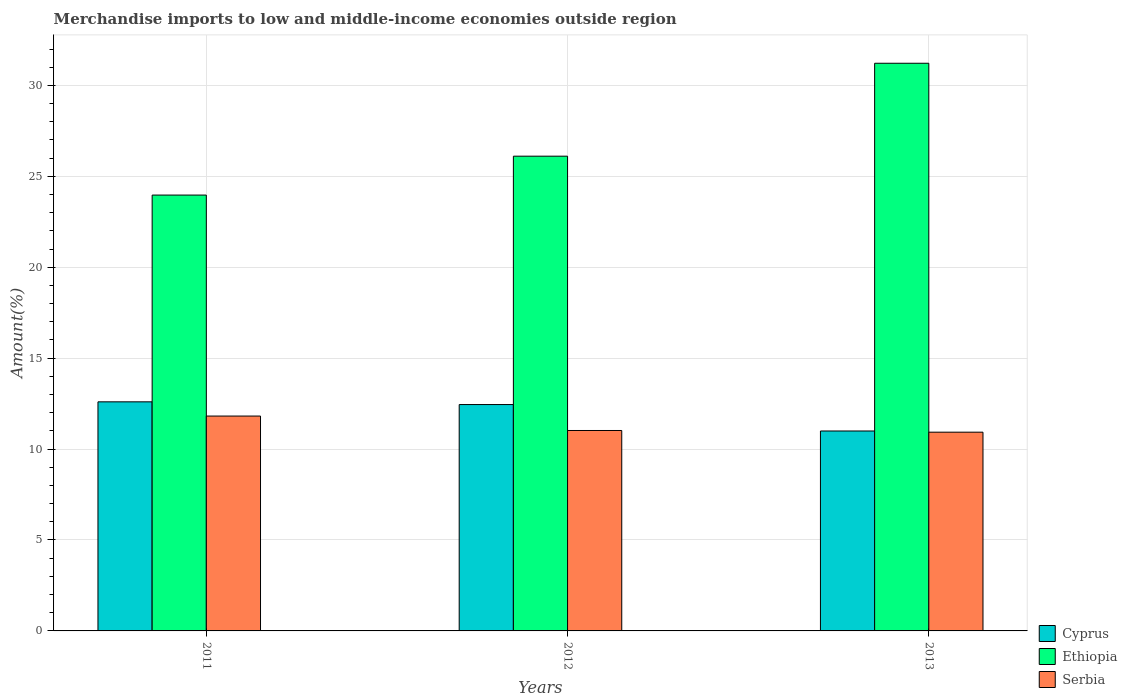Are the number of bars per tick equal to the number of legend labels?
Give a very brief answer. Yes. How many bars are there on the 3rd tick from the left?
Your answer should be compact. 3. What is the label of the 3rd group of bars from the left?
Offer a terse response. 2013. In how many cases, is the number of bars for a given year not equal to the number of legend labels?
Offer a terse response. 0. What is the percentage of amount earned from merchandise imports in Serbia in 2011?
Offer a terse response. 11.82. Across all years, what is the maximum percentage of amount earned from merchandise imports in Ethiopia?
Your response must be concise. 31.22. Across all years, what is the minimum percentage of amount earned from merchandise imports in Ethiopia?
Your response must be concise. 23.97. In which year was the percentage of amount earned from merchandise imports in Serbia maximum?
Ensure brevity in your answer.  2011. In which year was the percentage of amount earned from merchandise imports in Serbia minimum?
Ensure brevity in your answer.  2013. What is the total percentage of amount earned from merchandise imports in Ethiopia in the graph?
Provide a succinct answer. 81.29. What is the difference between the percentage of amount earned from merchandise imports in Serbia in 2011 and that in 2013?
Provide a short and direct response. 0.89. What is the difference between the percentage of amount earned from merchandise imports in Cyprus in 2011 and the percentage of amount earned from merchandise imports in Serbia in 2013?
Your answer should be compact. 1.67. What is the average percentage of amount earned from merchandise imports in Ethiopia per year?
Keep it short and to the point. 27.1. In the year 2013, what is the difference between the percentage of amount earned from merchandise imports in Cyprus and percentage of amount earned from merchandise imports in Ethiopia?
Your response must be concise. -20.22. In how many years, is the percentage of amount earned from merchandise imports in Ethiopia greater than 21 %?
Provide a short and direct response. 3. What is the ratio of the percentage of amount earned from merchandise imports in Serbia in 2012 to that in 2013?
Your answer should be compact. 1.01. Is the difference between the percentage of amount earned from merchandise imports in Cyprus in 2012 and 2013 greater than the difference between the percentage of amount earned from merchandise imports in Ethiopia in 2012 and 2013?
Your response must be concise. Yes. What is the difference between the highest and the second highest percentage of amount earned from merchandise imports in Cyprus?
Your response must be concise. 0.15. What is the difference between the highest and the lowest percentage of amount earned from merchandise imports in Serbia?
Keep it short and to the point. 0.89. In how many years, is the percentage of amount earned from merchandise imports in Cyprus greater than the average percentage of amount earned from merchandise imports in Cyprus taken over all years?
Your answer should be compact. 2. What does the 2nd bar from the left in 2012 represents?
Provide a succinct answer. Ethiopia. What does the 2nd bar from the right in 2013 represents?
Keep it short and to the point. Ethiopia. Are all the bars in the graph horizontal?
Ensure brevity in your answer.  No. How many legend labels are there?
Keep it short and to the point. 3. How are the legend labels stacked?
Ensure brevity in your answer.  Vertical. What is the title of the graph?
Your answer should be compact. Merchandise imports to low and middle-income economies outside region. Does "Suriname" appear as one of the legend labels in the graph?
Offer a terse response. No. What is the label or title of the Y-axis?
Make the answer very short. Amount(%). What is the Amount(%) of Cyprus in 2011?
Offer a terse response. 12.6. What is the Amount(%) in Ethiopia in 2011?
Give a very brief answer. 23.97. What is the Amount(%) of Serbia in 2011?
Your answer should be compact. 11.82. What is the Amount(%) in Cyprus in 2012?
Offer a terse response. 12.45. What is the Amount(%) of Ethiopia in 2012?
Your answer should be very brief. 26.11. What is the Amount(%) in Serbia in 2012?
Make the answer very short. 11.02. What is the Amount(%) of Cyprus in 2013?
Offer a terse response. 10.99. What is the Amount(%) in Ethiopia in 2013?
Your answer should be very brief. 31.22. What is the Amount(%) in Serbia in 2013?
Offer a terse response. 10.93. Across all years, what is the maximum Amount(%) of Cyprus?
Offer a terse response. 12.6. Across all years, what is the maximum Amount(%) in Ethiopia?
Your answer should be very brief. 31.22. Across all years, what is the maximum Amount(%) in Serbia?
Make the answer very short. 11.82. Across all years, what is the minimum Amount(%) in Cyprus?
Give a very brief answer. 10.99. Across all years, what is the minimum Amount(%) of Ethiopia?
Give a very brief answer. 23.97. Across all years, what is the minimum Amount(%) in Serbia?
Offer a very short reply. 10.93. What is the total Amount(%) of Cyprus in the graph?
Your answer should be very brief. 36.04. What is the total Amount(%) in Ethiopia in the graph?
Provide a succinct answer. 81.29. What is the total Amount(%) of Serbia in the graph?
Offer a very short reply. 33.77. What is the difference between the Amount(%) in Cyprus in 2011 and that in 2012?
Your answer should be compact. 0.15. What is the difference between the Amount(%) of Ethiopia in 2011 and that in 2012?
Offer a very short reply. -2.14. What is the difference between the Amount(%) of Serbia in 2011 and that in 2012?
Offer a terse response. 0.79. What is the difference between the Amount(%) of Cyprus in 2011 and that in 2013?
Give a very brief answer. 1.6. What is the difference between the Amount(%) of Ethiopia in 2011 and that in 2013?
Keep it short and to the point. -7.25. What is the difference between the Amount(%) of Serbia in 2011 and that in 2013?
Provide a short and direct response. 0.89. What is the difference between the Amount(%) in Cyprus in 2012 and that in 2013?
Give a very brief answer. 1.45. What is the difference between the Amount(%) of Ethiopia in 2012 and that in 2013?
Make the answer very short. -5.11. What is the difference between the Amount(%) in Serbia in 2012 and that in 2013?
Provide a short and direct response. 0.09. What is the difference between the Amount(%) in Cyprus in 2011 and the Amount(%) in Ethiopia in 2012?
Offer a terse response. -13.51. What is the difference between the Amount(%) in Cyprus in 2011 and the Amount(%) in Serbia in 2012?
Offer a very short reply. 1.58. What is the difference between the Amount(%) of Ethiopia in 2011 and the Amount(%) of Serbia in 2012?
Your answer should be compact. 12.95. What is the difference between the Amount(%) of Cyprus in 2011 and the Amount(%) of Ethiopia in 2013?
Your answer should be compact. -18.62. What is the difference between the Amount(%) in Cyprus in 2011 and the Amount(%) in Serbia in 2013?
Make the answer very short. 1.67. What is the difference between the Amount(%) in Ethiopia in 2011 and the Amount(%) in Serbia in 2013?
Ensure brevity in your answer.  13.04. What is the difference between the Amount(%) in Cyprus in 2012 and the Amount(%) in Ethiopia in 2013?
Offer a very short reply. -18.77. What is the difference between the Amount(%) in Cyprus in 2012 and the Amount(%) in Serbia in 2013?
Provide a succinct answer. 1.52. What is the difference between the Amount(%) in Ethiopia in 2012 and the Amount(%) in Serbia in 2013?
Your answer should be very brief. 15.18. What is the average Amount(%) in Cyprus per year?
Ensure brevity in your answer.  12.01. What is the average Amount(%) in Ethiopia per year?
Give a very brief answer. 27.1. What is the average Amount(%) of Serbia per year?
Provide a succinct answer. 11.26. In the year 2011, what is the difference between the Amount(%) of Cyprus and Amount(%) of Ethiopia?
Your response must be concise. -11.37. In the year 2011, what is the difference between the Amount(%) in Cyprus and Amount(%) in Serbia?
Give a very brief answer. 0.78. In the year 2011, what is the difference between the Amount(%) of Ethiopia and Amount(%) of Serbia?
Provide a short and direct response. 12.15. In the year 2012, what is the difference between the Amount(%) of Cyprus and Amount(%) of Ethiopia?
Your answer should be compact. -13.66. In the year 2012, what is the difference between the Amount(%) in Cyprus and Amount(%) in Serbia?
Offer a terse response. 1.43. In the year 2012, what is the difference between the Amount(%) in Ethiopia and Amount(%) in Serbia?
Your answer should be very brief. 15.09. In the year 2013, what is the difference between the Amount(%) of Cyprus and Amount(%) of Ethiopia?
Offer a very short reply. -20.22. In the year 2013, what is the difference between the Amount(%) in Cyprus and Amount(%) in Serbia?
Give a very brief answer. 0.07. In the year 2013, what is the difference between the Amount(%) of Ethiopia and Amount(%) of Serbia?
Your answer should be compact. 20.29. What is the ratio of the Amount(%) of Cyprus in 2011 to that in 2012?
Your answer should be very brief. 1.01. What is the ratio of the Amount(%) of Ethiopia in 2011 to that in 2012?
Make the answer very short. 0.92. What is the ratio of the Amount(%) in Serbia in 2011 to that in 2012?
Keep it short and to the point. 1.07. What is the ratio of the Amount(%) of Cyprus in 2011 to that in 2013?
Offer a very short reply. 1.15. What is the ratio of the Amount(%) in Ethiopia in 2011 to that in 2013?
Provide a short and direct response. 0.77. What is the ratio of the Amount(%) of Serbia in 2011 to that in 2013?
Make the answer very short. 1.08. What is the ratio of the Amount(%) in Cyprus in 2012 to that in 2013?
Your answer should be compact. 1.13. What is the ratio of the Amount(%) of Ethiopia in 2012 to that in 2013?
Your response must be concise. 0.84. What is the ratio of the Amount(%) in Serbia in 2012 to that in 2013?
Provide a short and direct response. 1.01. What is the difference between the highest and the second highest Amount(%) of Cyprus?
Provide a succinct answer. 0.15. What is the difference between the highest and the second highest Amount(%) in Ethiopia?
Provide a succinct answer. 5.11. What is the difference between the highest and the second highest Amount(%) in Serbia?
Make the answer very short. 0.79. What is the difference between the highest and the lowest Amount(%) in Cyprus?
Your answer should be compact. 1.6. What is the difference between the highest and the lowest Amount(%) of Ethiopia?
Your answer should be compact. 7.25. What is the difference between the highest and the lowest Amount(%) of Serbia?
Offer a terse response. 0.89. 